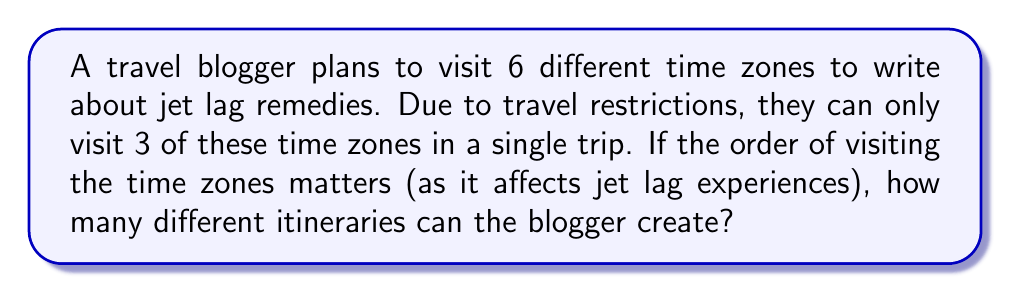Solve this math problem. Let's approach this step-by-step:

1) This problem is a permutation problem, specifically an arrangement without repetition.

2) We have 6 time zones to choose from (n = 6), and we're selecting 3 at a time (r = 3).

3) The order matters, as the sequence of time zones visited affects the jet lag experience.

4) The formula for permutations without repetition is:

   $$P(n,r) = \frac{n!}{(n-r)!}$$

5) Substituting our values:

   $$P(6,3) = \frac{6!}{(6-3)!} = \frac{6!}{3!}$$

6) Expanding this:

   $$\frac{6 \times 5 \times 4 \times 3!}{3!}$$

7) The 3! cancels out in the numerator and denominator:

   $$6 \times 5 \times 4 = 120$$

Therefore, the travel blogger can create 120 different itineraries.
Answer: 120 